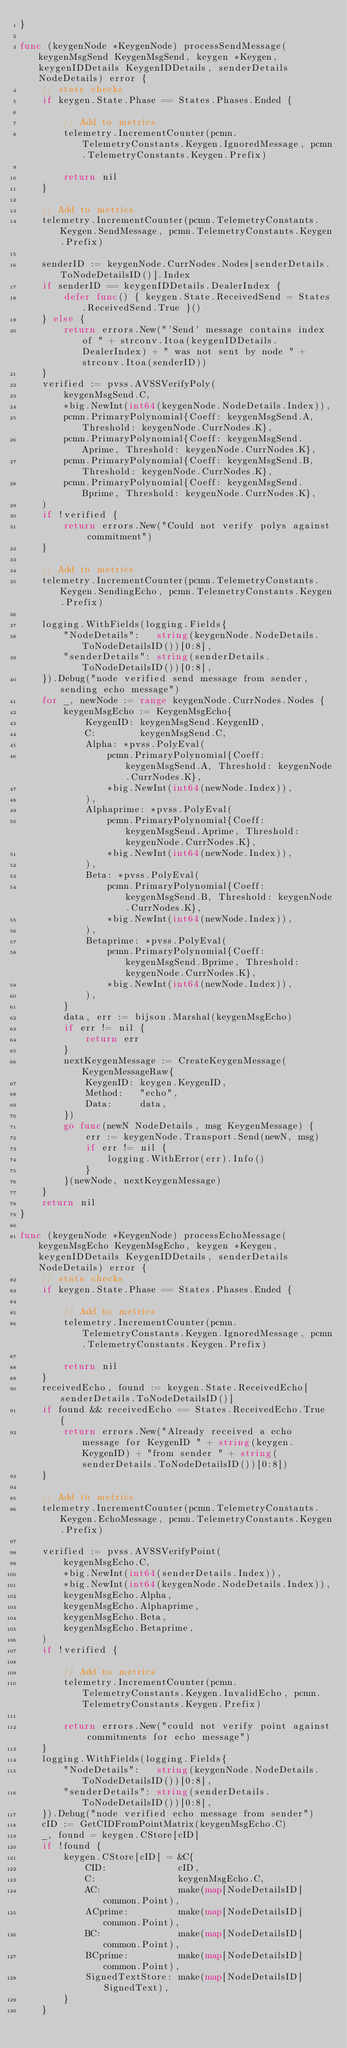<code> <loc_0><loc_0><loc_500><loc_500><_Go_>}

func (keygenNode *KeygenNode) processSendMessage(keygenMsgSend KeygenMsgSend, keygen *Keygen, keygenIDDetails KeygenIDDetails, senderDetails NodeDetails) error {
	// state checks
	if keygen.State.Phase == States.Phases.Ended {

		// Add to metrics
		telemetry.IncrementCounter(pcmn.TelemetryConstants.Keygen.IgnoredMessage, pcmn.TelemetryConstants.Keygen.Prefix)

		return nil
	}

	// Add to metrics
	telemetry.IncrementCounter(pcmn.TelemetryConstants.Keygen.SendMessage, pcmn.TelemetryConstants.Keygen.Prefix)

	senderID := keygenNode.CurrNodes.Nodes[senderDetails.ToNodeDetailsID()].Index
	if senderID == keygenIDDetails.DealerIndex {
		defer func() { keygen.State.ReceivedSend = States.ReceivedSend.True }()
	} else {
		return errors.New("'Send' message contains index of " + strconv.Itoa(keygenIDDetails.DealerIndex) + " was not sent by node " + strconv.Itoa(senderID))
	}
	verified := pvss.AVSSVerifyPoly(
		keygenMsgSend.C,
		*big.NewInt(int64(keygenNode.NodeDetails.Index)),
		pcmn.PrimaryPolynomial{Coeff: keygenMsgSend.A, Threshold: keygenNode.CurrNodes.K},
		pcmn.PrimaryPolynomial{Coeff: keygenMsgSend.Aprime, Threshold: keygenNode.CurrNodes.K},
		pcmn.PrimaryPolynomial{Coeff: keygenMsgSend.B, Threshold: keygenNode.CurrNodes.K},
		pcmn.PrimaryPolynomial{Coeff: keygenMsgSend.Bprime, Threshold: keygenNode.CurrNodes.K},
	)
	if !verified {
		return errors.New("Could not verify polys against commitment")
	}

	// Add to metrics
	telemetry.IncrementCounter(pcmn.TelemetryConstants.Keygen.SendingEcho, pcmn.TelemetryConstants.Keygen.Prefix)

	logging.WithFields(logging.Fields{
		"NodeDetails":   string(keygenNode.NodeDetails.ToNodeDetailsID())[0:8],
		"senderDetails": string(senderDetails.ToNodeDetailsID())[0:8],
	}).Debug("node verified send message from sender, sending echo message")
	for _, newNode := range keygenNode.CurrNodes.Nodes {
		keygenMsgEcho := KeygenMsgEcho{
			KeygenID: keygenMsgSend.KeygenID,
			C:        keygenMsgSend.C,
			Alpha: *pvss.PolyEval(
				pcmn.PrimaryPolynomial{Coeff: keygenMsgSend.A, Threshold: keygenNode.CurrNodes.K},
				*big.NewInt(int64(newNode.Index)),
			),
			Alphaprime: *pvss.PolyEval(
				pcmn.PrimaryPolynomial{Coeff: keygenMsgSend.Aprime, Threshold: keygenNode.CurrNodes.K},
				*big.NewInt(int64(newNode.Index)),
			),
			Beta: *pvss.PolyEval(
				pcmn.PrimaryPolynomial{Coeff: keygenMsgSend.B, Threshold: keygenNode.CurrNodes.K},
				*big.NewInt(int64(newNode.Index)),
			),
			Betaprime: *pvss.PolyEval(
				pcmn.PrimaryPolynomial{Coeff: keygenMsgSend.Bprime, Threshold: keygenNode.CurrNodes.K},
				*big.NewInt(int64(newNode.Index)),
			),
		}
		data, err := bijson.Marshal(keygenMsgEcho)
		if err != nil {
			return err
		}
		nextKeygenMessage := CreateKeygenMessage(KeygenMessageRaw{
			KeygenID: keygen.KeygenID,
			Method:   "echo",
			Data:     data,
		})
		go func(newN NodeDetails, msg KeygenMessage) {
			err := keygenNode.Transport.Send(newN, msg)
			if err != nil {
				logging.WithError(err).Info()
			}
		}(newNode, nextKeygenMessage)
	}
	return nil
}

func (keygenNode *KeygenNode) processEchoMessage(keygenMsgEcho KeygenMsgEcho, keygen *Keygen, keygenIDDetails KeygenIDDetails, senderDetails NodeDetails) error {
	// state checks
	if keygen.State.Phase == States.Phases.Ended {

		// Add to metrics
		telemetry.IncrementCounter(pcmn.TelemetryConstants.Keygen.IgnoredMessage, pcmn.TelemetryConstants.Keygen.Prefix)

		return nil
	}
	receivedEcho, found := keygen.State.ReceivedEcho[senderDetails.ToNodeDetailsID()]
	if found && receivedEcho == States.ReceivedEcho.True {
		return errors.New("Already received a echo message for KeygenID " + string(keygen.KeygenID) + "from sender " + string(senderDetails.ToNodeDetailsID())[0:8])
	}

	// Add to metrics
	telemetry.IncrementCounter(pcmn.TelemetryConstants.Keygen.EchoMessage, pcmn.TelemetryConstants.Keygen.Prefix)

	verified := pvss.AVSSVerifyPoint(
		keygenMsgEcho.C,
		*big.NewInt(int64(senderDetails.Index)),
		*big.NewInt(int64(keygenNode.NodeDetails.Index)),
		keygenMsgEcho.Alpha,
		keygenMsgEcho.Alphaprime,
		keygenMsgEcho.Beta,
		keygenMsgEcho.Betaprime,
	)
	if !verified {

		// Add to metrics
		telemetry.IncrementCounter(pcmn.TelemetryConstants.Keygen.InvalidEcho, pcmn.TelemetryConstants.Keygen.Prefix)

		return errors.New("could not verify point against commitments for echo message")
	}
	logging.WithFields(logging.Fields{
		"NodeDetails":   string(keygenNode.NodeDetails.ToNodeDetailsID())[0:8],
		"senderDetails": string(senderDetails.ToNodeDetailsID())[0:8],
	}).Debug("node verified echo message from sender")
	cID := GetCIDFromPointMatrix(keygenMsgEcho.C)
	_, found = keygen.CStore[cID]
	if !found {
		keygen.CStore[cID] = &C{
			CID:             cID,
			C:               keygenMsgEcho.C,
			AC:              make(map[NodeDetailsID]common.Point),
			ACprime:         make(map[NodeDetailsID]common.Point),
			BC:              make(map[NodeDetailsID]common.Point),
			BCprime:         make(map[NodeDetailsID]common.Point),
			SignedTextStore: make(map[NodeDetailsID]SignedText),
		}
	}</code> 